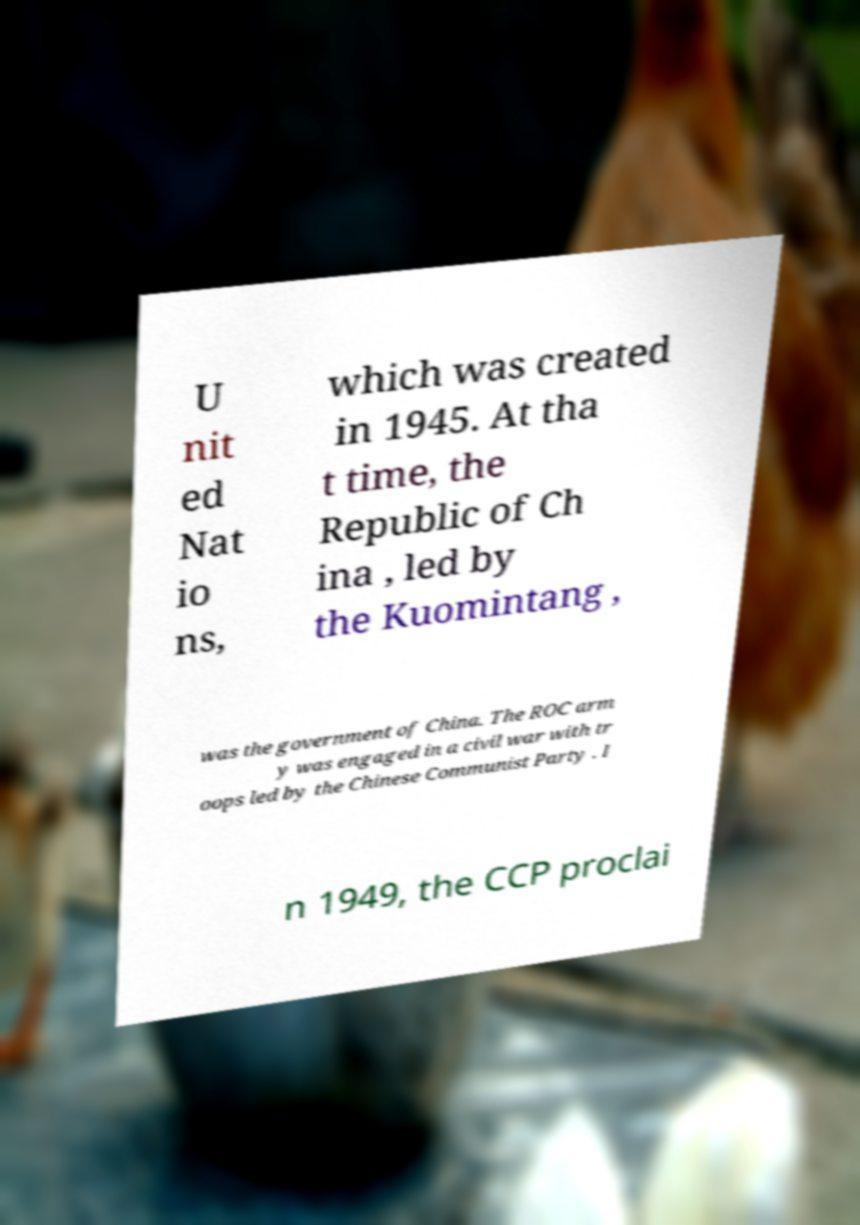I need the written content from this picture converted into text. Can you do that? U nit ed Nat io ns, which was created in 1945. At tha t time, the Republic of Ch ina , led by the Kuomintang , was the government of China. The ROC arm y was engaged in a civil war with tr oops led by the Chinese Communist Party . I n 1949, the CCP proclai 